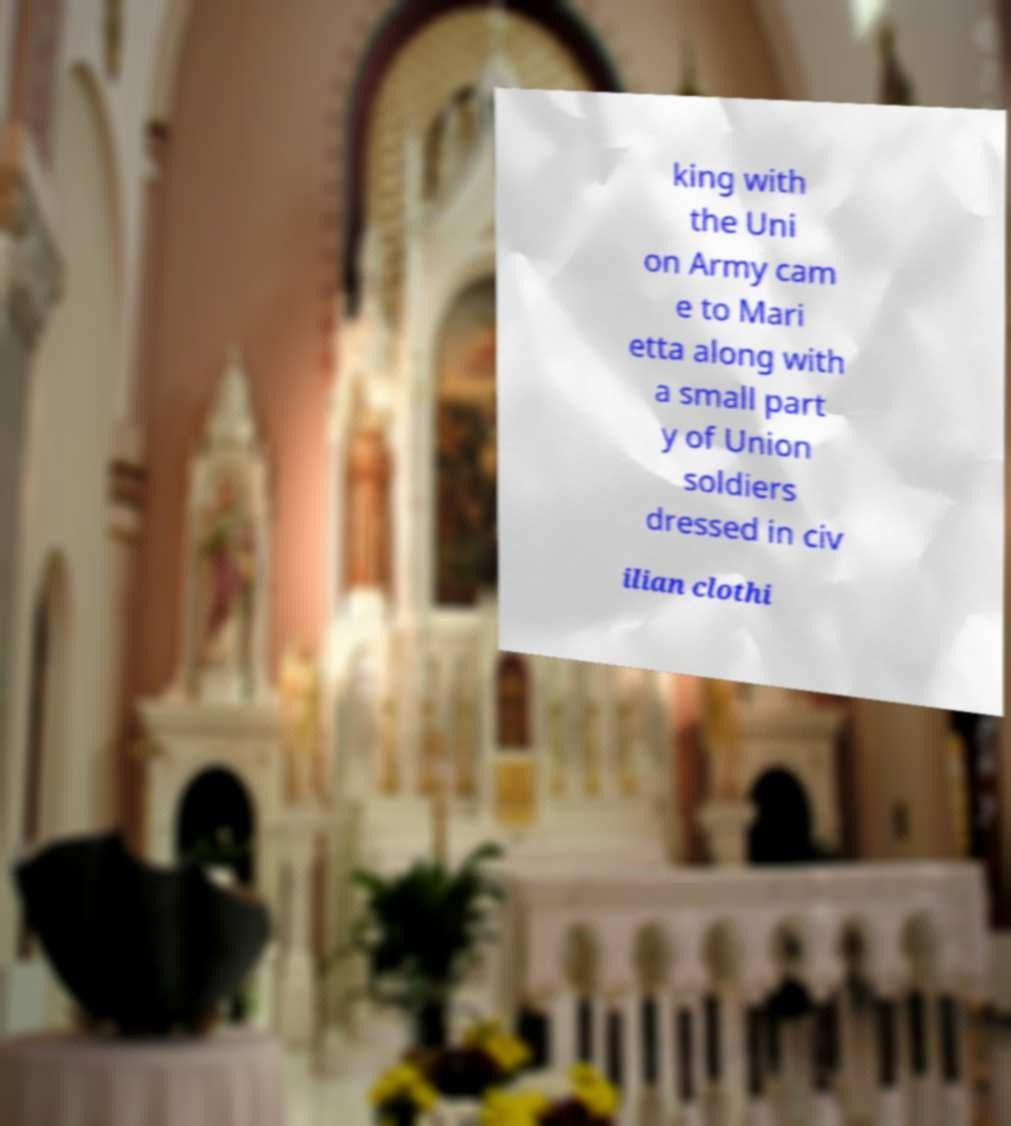Could you extract and type out the text from this image? king with the Uni on Army cam e to Mari etta along with a small part y of Union soldiers dressed in civ ilian clothi 